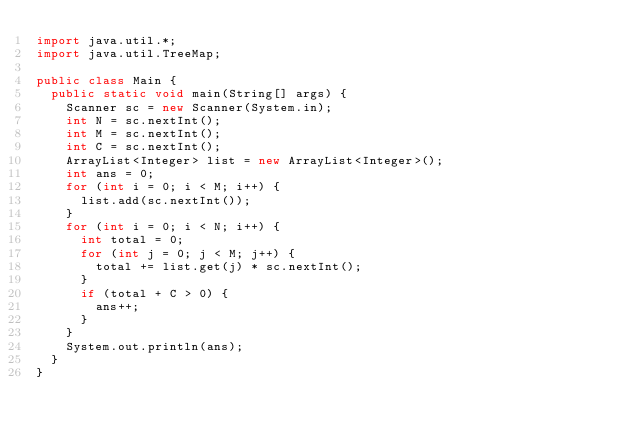Convert code to text. <code><loc_0><loc_0><loc_500><loc_500><_Java_>import java.util.*;
import java.util.TreeMap;

public class Main {
  public static void main(String[] args) {
    Scanner sc = new Scanner(System.in);
    int N = sc.nextInt();
    int M = sc.nextInt();
    int C = sc.nextInt();
    ArrayList<Integer> list = new ArrayList<Integer>();
    int ans = 0;
    for (int i = 0; i < M; i++) {
      list.add(sc.nextInt());
    }
    for (int i = 0; i < N; i++) {
      int total = 0;
      for (int j = 0; j < M; j++) {
        total += list.get(j) * sc.nextInt();
      }
      if (total + C > 0) {
        ans++;
      }
    }
    System.out.println(ans);
  }
}
</code> 